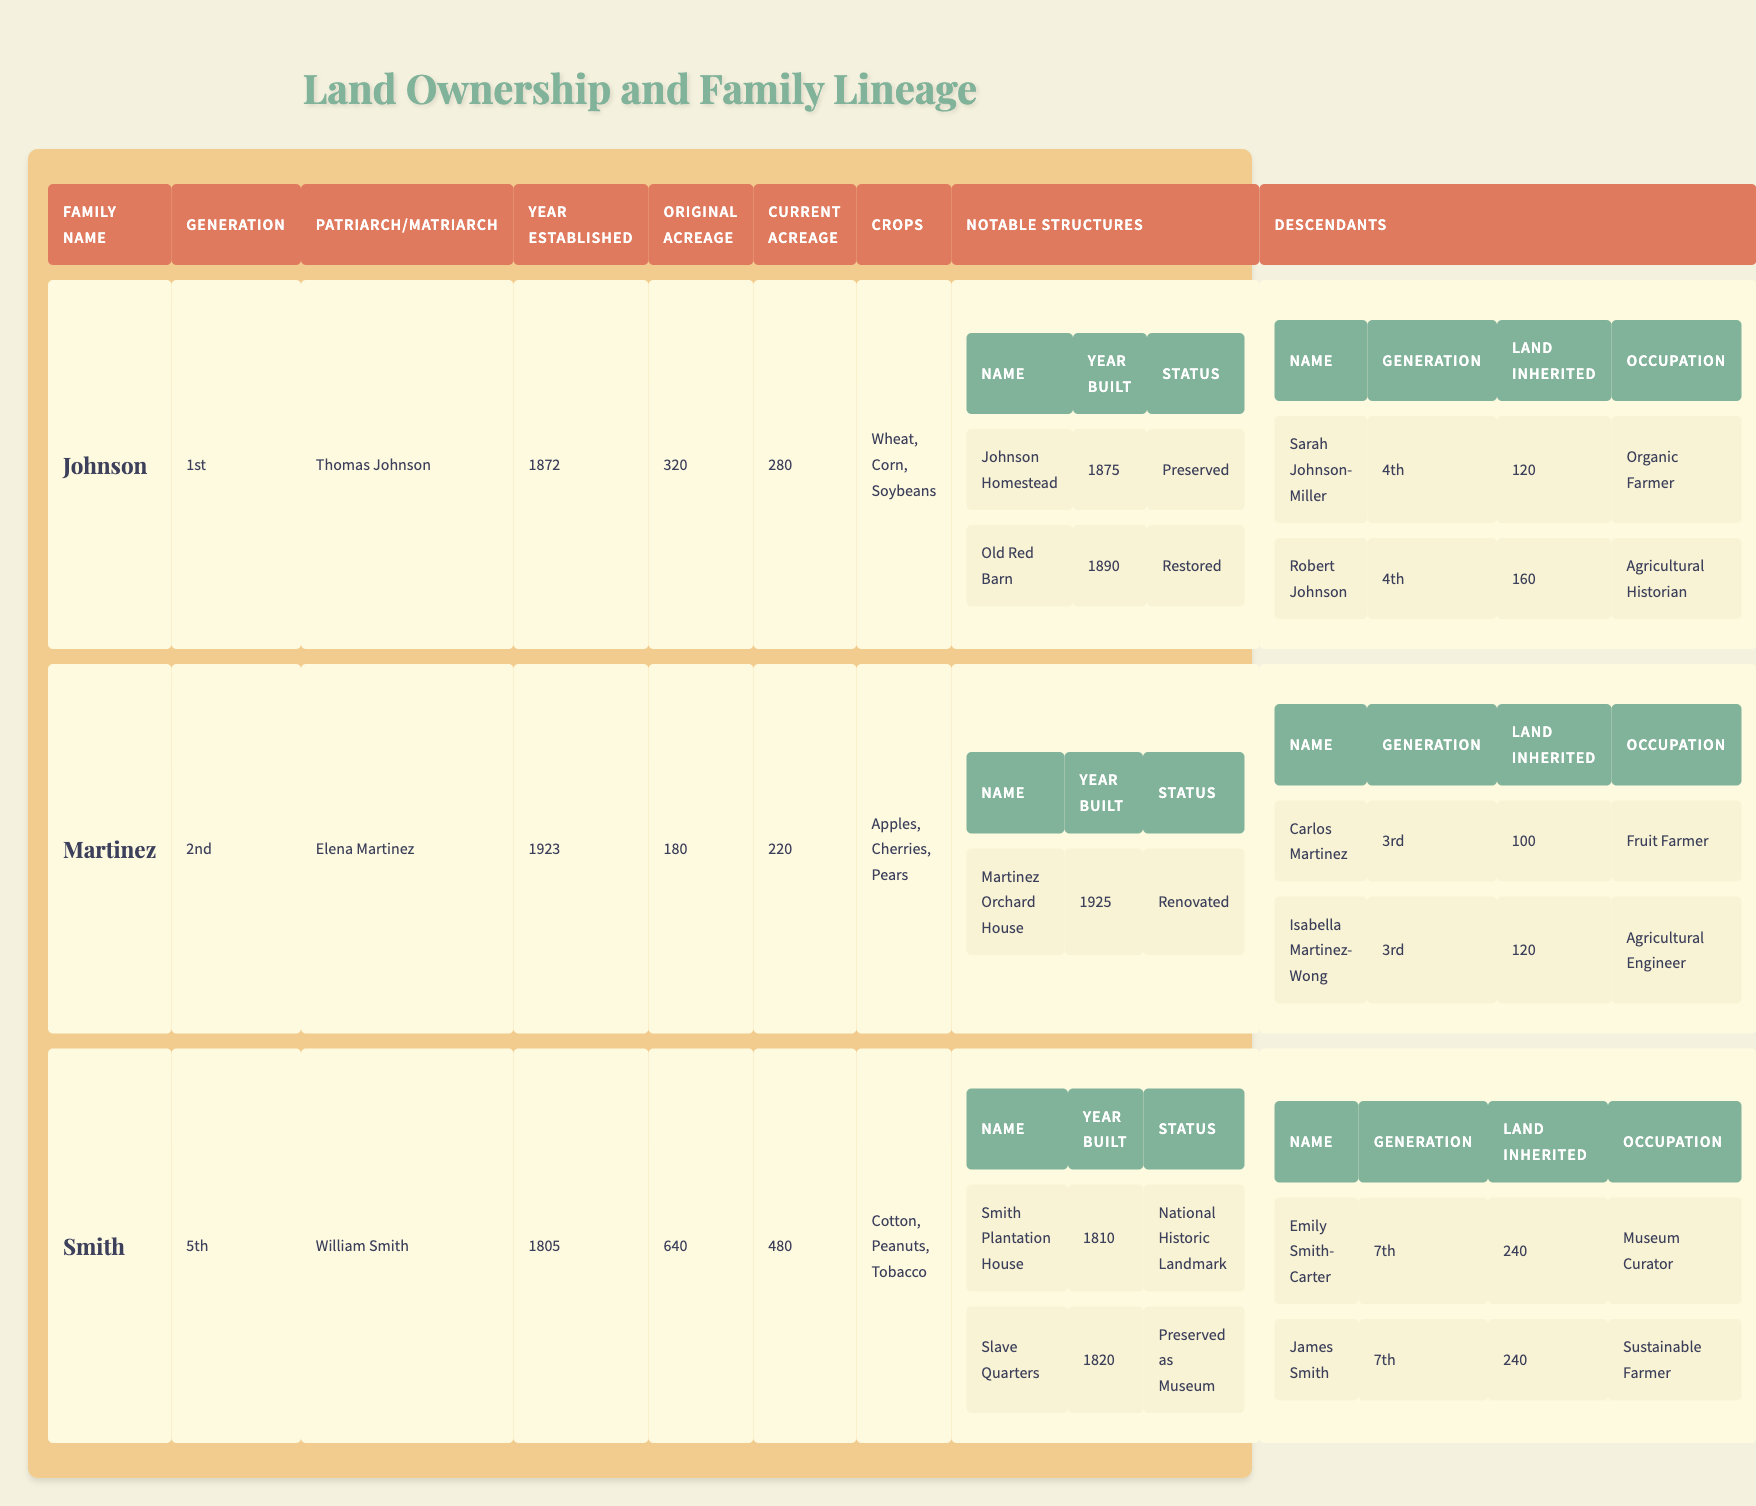What is the original acreage of the Johnson family land? The original acreage for the Johnson family is listed in the table under the "Original Acreage" column for the Johnson family, which shows 320 acres.
Answer: 320 acres Who occupies the position of Matriarch in the Martinez family? The Matriarch of the Martinez family is found in the "Patriarch/Matriarch" column, which states that Elena Martinez holds this position.
Answer: Elena Martinez What is the status of the Smith Plantation House? By checking the "Notable Structures" section for the Smith family, the status for the Smith Plantation House is identified as "National Historic Landmark."
Answer: National Historic Landmark How many acres did Sarah Johnson-Miller inherit? The table indicates that Sarah Johnson-Miller, a descendant of the Johnson family, inherited 120 acres as mentioned in the "Land Inherited" column for her entry.
Answer: 120 acres What crops do the Martinez family grow? The crops cultivated by the Martinez family are listed under the "Crops" section and include Apples, Cherries, and Pears.
Answer: Apples, Cherries, Pears What is the difference in acreage between the original and current for the Smith family? For the Smith family, the original acreage is 640 and the current acreage is 480. The difference is calculated as 640 - 480 = 160 acres.
Answer: 160 acres Which descendant of the Johnson family is an Agricultural Historian? By examining the "Descendants" section for the Johnson family, Robert Johnson is listed as the one with the occupation of Agricultural Historian.
Answer: Robert Johnson Is the Johnson Homestead a preserved structure? The status of the Johnson Homestead under the "Notable Structures" section confirms that it is marked as "Preserved," validating the fact.
Answer: Yes What is the total inherited land for the seventh-generation descendants of the Smith family? Emily Smith-Carter and James Smith, both seventh-generation descendants, inherited equal amounts of 240 acres each. Thus, the total inherited land is 240 + 240 = 480 acres.
Answer: 480 acres Which family has the latest establishment year and what is that year? The family with the latest year of establishment is the Martinez family, established in 1923, which can be verified in the "Year Established" column.
Answer: 1923 